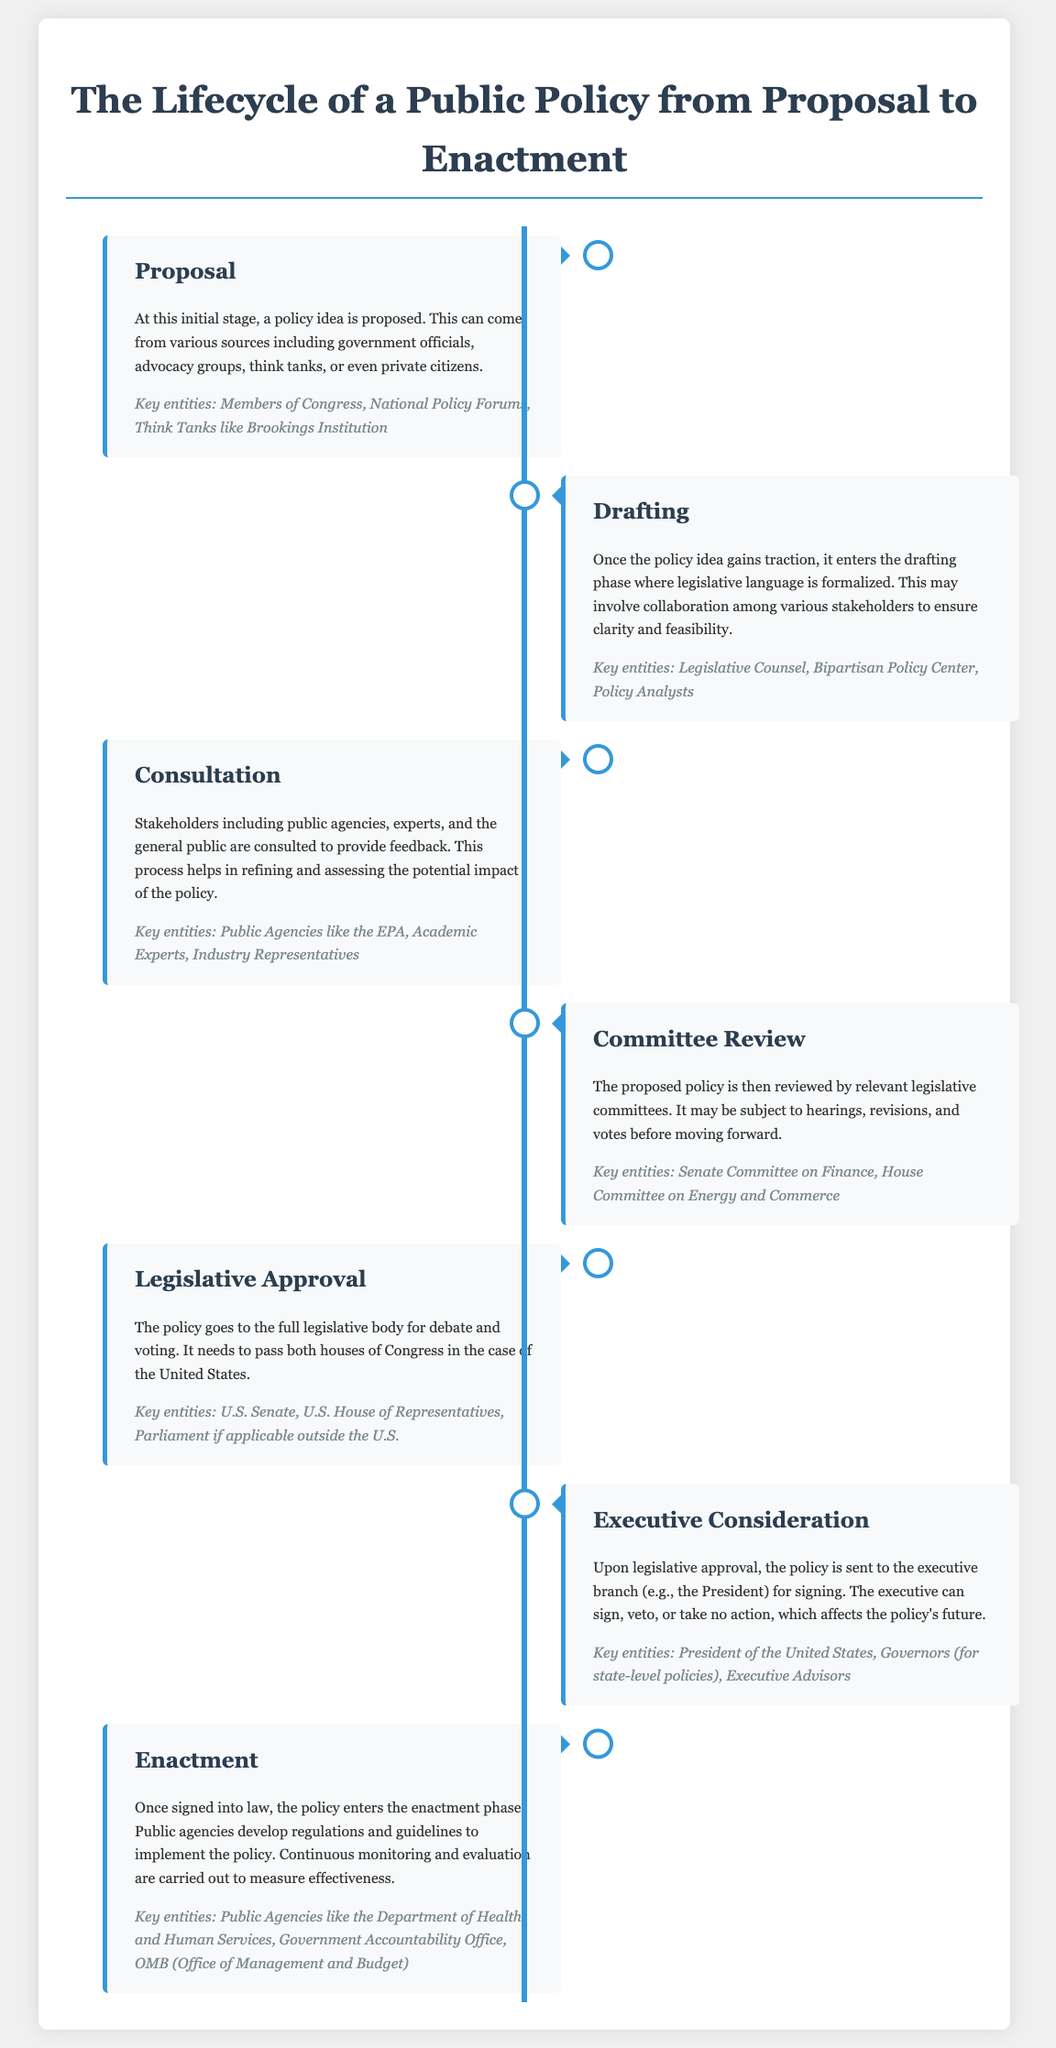What stage follows the proposal? The stage that follows the proposal is characterized by the drafting of legislative language and clarification of the policy idea. This is noted as the second stage in the process.
Answer: Drafting Who are key entities involved in the consultation phase? The consultation phase includes various stakeholders providing feedback on the proposed policy, and key entities mentioned are organizations and individuals in this category.
Answer: Public Agencies like the EPA What must happen for a policy to progress to executive consideration? The policy must pass through earlier stages, specifically gaining approval from a relevant body. Thus, understanding the legislative body’s decision is essential.
Answer: Legislative Approval What happens during the committee review stage? In this stage, the proposed policy undergoes scrutiny from legislative committees, which involves further evaluations and decision-making.
Answer: Hearings, revisions, and votes What entity is responsible for signing the policy into law? The executive branch plays a crucial role in the enactment process by deciding on the proposal's future.
Answer: President of the United States How many legislative bodies are involved in the U.S. approval process? This question targets the structure of the legislative system in the U.S. as referred to within the context of policy enactment.
Answer: Two 